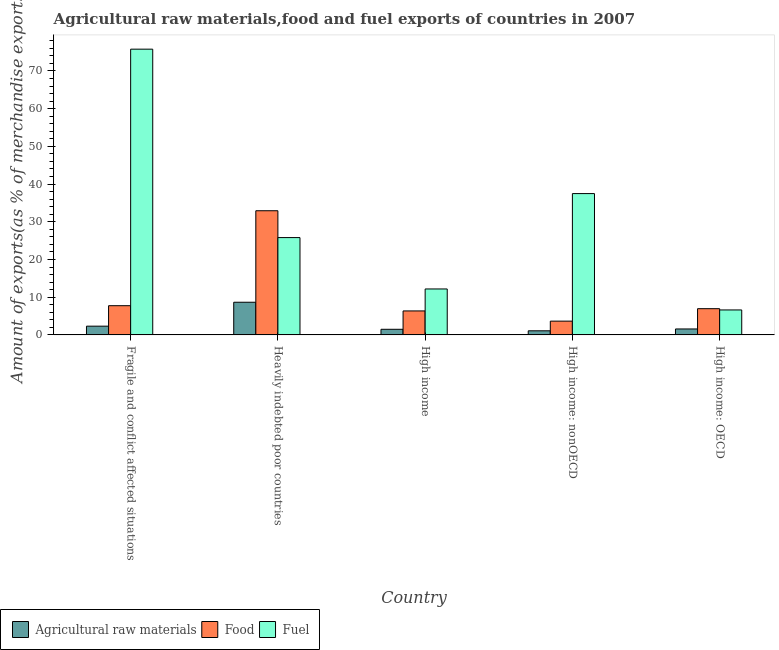How many different coloured bars are there?
Offer a terse response. 3. How many groups of bars are there?
Your answer should be very brief. 5. How many bars are there on the 4th tick from the right?
Make the answer very short. 3. What is the label of the 1st group of bars from the left?
Keep it short and to the point. Fragile and conflict affected situations. In how many cases, is the number of bars for a given country not equal to the number of legend labels?
Your answer should be very brief. 0. What is the percentage of food exports in High income: nonOECD?
Your response must be concise. 3.65. Across all countries, what is the maximum percentage of raw materials exports?
Offer a very short reply. 8.66. Across all countries, what is the minimum percentage of food exports?
Your answer should be very brief. 3.65. In which country was the percentage of raw materials exports maximum?
Keep it short and to the point. Heavily indebted poor countries. In which country was the percentage of raw materials exports minimum?
Provide a short and direct response. High income: nonOECD. What is the total percentage of fuel exports in the graph?
Offer a terse response. 157.86. What is the difference between the percentage of food exports in Heavily indebted poor countries and that in High income: OECD?
Your answer should be very brief. 25.97. What is the difference between the percentage of raw materials exports in High income: nonOECD and the percentage of fuel exports in Fragile and conflict affected situations?
Make the answer very short. -74.68. What is the average percentage of raw materials exports per country?
Your response must be concise. 3.03. What is the difference between the percentage of fuel exports and percentage of food exports in High income: OECD?
Your response must be concise. -0.33. In how many countries, is the percentage of food exports greater than 14 %?
Make the answer very short. 1. What is the ratio of the percentage of food exports in Fragile and conflict affected situations to that in High income?
Your answer should be compact. 1.22. Is the percentage of fuel exports in Fragile and conflict affected situations less than that in High income: OECD?
Offer a very short reply. No. Is the difference between the percentage of food exports in Heavily indebted poor countries and High income: nonOECD greater than the difference between the percentage of raw materials exports in Heavily indebted poor countries and High income: nonOECD?
Your answer should be compact. Yes. What is the difference between the highest and the second highest percentage of food exports?
Offer a very short reply. 25.18. What is the difference between the highest and the lowest percentage of fuel exports?
Make the answer very short. 69.15. In how many countries, is the percentage of food exports greater than the average percentage of food exports taken over all countries?
Your response must be concise. 1. Is the sum of the percentage of fuel exports in Fragile and conflict affected situations and Heavily indebted poor countries greater than the maximum percentage of food exports across all countries?
Your answer should be compact. Yes. What does the 3rd bar from the left in Heavily indebted poor countries represents?
Give a very brief answer. Fuel. What does the 1st bar from the right in High income: OECD represents?
Ensure brevity in your answer.  Fuel. Are all the bars in the graph horizontal?
Offer a very short reply. No. How many countries are there in the graph?
Offer a very short reply. 5. Does the graph contain any zero values?
Your answer should be compact. No. How many legend labels are there?
Give a very brief answer. 3. How are the legend labels stacked?
Ensure brevity in your answer.  Horizontal. What is the title of the graph?
Provide a short and direct response. Agricultural raw materials,food and fuel exports of countries in 2007. Does "Tertiary" appear as one of the legend labels in the graph?
Offer a terse response. No. What is the label or title of the Y-axis?
Keep it short and to the point. Amount of exports(as % of merchandise exports). What is the Amount of exports(as % of merchandise exports) in Agricultural raw materials in Fragile and conflict affected situations?
Make the answer very short. 2.32. What is the Amount of exports(as % of merchandise exports) in Food in Fragile and conflict affected situations?
Give a very brief answer. 7.75. What is the Amount of exports(as % of merchandise exports) in Fuel in Fragile and conflict affected situations?
Give a very brief answer. 75.77. What is the Amount of exports(as % of merchandise exports) in Agricultural raw materials in Heavily indebted poor countries?
Provide a succinct answer. 8.66. What is the Amount of exports(as % of merchandise exports) of Food in Heavily indebted poor countries?
Your response must be concise. 32.92. What is the Amount of exports(as % of merchandise exports) of Fuel in Heavily indebted poor countries?
Your response must be concise. 25.81. What is the Amount of exports(as % of merchandise exports) in Agricultural raw materials in High income?
Keep it short and to the point. 1.49. What is the Amount of exports(as % of merchandise exports) in Food in High income?
Provide a succinct answer. 6.36. What is the Amount of exports(as % of merchandise exports) in Fuel in High income?
Keep it short and to the point. 12.18. What is the Amount of exports(as % of merchandise exports) in Agricultural raw materials in High income: nonOECD?
Keep it short and to the point. 1.09. What is the Amount of exports(as % of merchandise exports) in Food in High income: nonOECD?
Your response must be concise. 3.65. What is the Amount of exports(as % of merchandise exports) of Fuel in High income: nonOECD?
Give a very brief answer. 37.48. What is the Amount of exports(as % of merchandise exports) in Agricultural raw materials in High income: OECD?
Ensure brevity in your answer.  1.58. What is the Amount of exports(as % of merchandise exports) of Food in High income: OECD?
Keep it short and to the point. 6.95. What is the Amount of exports(as % of merchandise exports) in Fuel in High income: OECD?
Offer a terse response. 6.62. Across all countries, what is the maximum Amount of exports(as % of merchandise exports) in Agricultural raw materials?
Keep it short and to the point. 8.66. Across all countries, what is the maximum Amount of exports(as % of merchandise exports) of Food?
Make the answer very short. 32.92. Across all countries, what is the maximum Amount of exports(as % of merchandise exports) of Fuel?
Keep it short and to the point. 75.77. Across all countries, what is the minimum Amount of exports(as % of merchandise exports) of Agricultural raw materials?
Keep it short and to the point. 1.09. Across all countries, what is the minimum Amount of exports(as % of merchandise exports) in Food?
Ensure brevity in your answer.  3.65. Across all countries, what is the minimum Amount of exports(as % of merchandise exports) of Fuel?
Give a very brief answer. 6.62. What is the total Amount of exports(as % of merchandise exports) in Agricultural raw materials in the graph?
Provide a succinct answer. 15.14. What is the total Amount of exports(as % of merchandise exports) in Food in the graph?
Offer a very short reply. 57.63. What is the total Amount of exports(as % of merchandise exports) of Fuel in the graph?
Offer a very short reply. 157.86. What is the difference between the Amount of exports(as % of merchandise exports) of Agricultural raw materials in Fragile and conflict affected situations and that in Heavily indebted poor countries?
Keep it short and to the point. -6.34. What is the difference between the Amount of exports(as % of merchandise exports) in Food in Fragile and conflict affected situations and that in Heavily indebted poor countries?
Give a very brief answer. -25.18. What is the difference between the Amount of exports(as % of merchandise exports) in Fuel in Fragile and conflict affected situations and that in Heavily indebted poor countries?
Ensure brevity in your answer.  49.96. What is the difference between the Amount of exports(as % of merchandise exports) in Agricultural raw materials in Fragile and conflict affected situations and that in High income?
Your answer should be compact. 0.83. What is the difference between the Amount of exports(as % of merchandise exports) of Food in Fragile and conflict affected situations and that in High income?
Your answer should be very brief. 1.39. What is the difference between the Amount of exports(as % of merchandise exports) in Fuel in Fragile and conflict affected situations and that in High income?
Provide a succinct answer. 63.59. What is the difference between the Amount of exports(as % of merchandise exports) of Agricultural raw materials in Fragile and conflict affected situations and that in High income: nonOECD?
Offer a terse response. 1.23. What is the difference between the Amount of exports(as % of merchandise exports) of Food in Fragile and conflict affected situations and that in High income: nonOECD?
Give a very brief answer. 4.09. What is the difference between the Amount of exports(as % of merchandise exports) in Fuel in Fragile and conflict affected situations and that in High income: nonOECD?
Your answer should be very brief. 38.29. What is the difference between the Amount of exports(as % of merchandise exports) of Agricultural raw materials in Fragile and conflict affected situations and that in High income: OECD?
Your response must be concise. 0.74. What is the difference between the Amount of exports(as % of merchandise exports) of Food in Fragile and conflict affected situations and that in High income: OECD?
Provide a succinct answer. 0.79. What is the difference between the Amount of exports(as % of merchandise exports) of Fuel in Fragile and conflict affected situations and that in High income: OECD?
Give a very brief answer. 69.15. What is the difference between the Amount of exports(as % of merchandise exports) in Agricultural raw materials in Heavily indebted poor countries and that in High income?
Keep it short and to the point. 7.17. What is the difference between the Amount of exports(as % of merchandise exports) in Food in Heavily indebted poor countries and that in High income?
Provide a short and direct response. 26.57. What is the difference between the Amount of exports(as % of merchandise exports) of Fuel in Heavily indebted poor countries and that in High income?
Your answer should be very brief. 13.62. What is the difference between the Amount of exports(as % of merchandise exports) in Agricultural raw materials in Heavily indebted poor countries and that in High income: nonOECD?
Your answer should be compact. 7.57. What is the difference between the Amount of exports(as % of merchandise exports) of Food in Heavily indebted poor countries and that in High income: nonOECD?
Ensure brevity in your answer.  29.27. What is the difference between the Amount of exports(as % of merchandise exports) of Fuel in Heavily indebted poor countries and that in High income: nonOECD?
Ensure brevity in your answer.  -11.67. What is the difference between the Amount of exports(as % of merchandise exports) of Agricultural raw materials in Heavily indebted poor countries and that in High income: OECD?
Offer a very short reply. 7.08. What is the difference between the Amount of exports(as % of merchandise exports) of Food in Heavily indebted poor countries and that in High income: OECD?
Your answer should be very brief. 25.97. What is the difference between the Amount of exports(as % of merchandise exports) in Fuel in Heavily indebted poor countries and that in High income: OECD?
Your answer should be compact. 19.18. What is the difference between the Amount of exports(as % of merchandise exports) in Agricultural raw materials in High income and that in High income: nonOECD?
Give a very brief answer. 0.4. What is the difference between the Amount of exports(as % of merchandise exports) in Food in High income and that in High income: nonOECD?
Keep it short and to the point. 2.71. What is the difference between the Amount of exports(as % of merchandise exports) in Fuel in High income and that in High income: nonOECD?
Ensure brevity in your answer.  -25.29. What is the difference between the Amount of exports(as % of merchandise exports) in Agricultural raw materials in High income and that in High income: OECD?
Offer a terse response. -0.09. What is the difference between the Amount of exports(as % of merchandise exports) of Food in High income and that in High income: OECD?
Your answer should be very brief. -0.6. What is the difference between the Amount of exports(as % of merchandise exports) in Fuel in High income and that in High income: OECD?
Provide a short and direct response. 5.56. What is the difference between the Amount of exports(as % of merchandise exports) in Agricultural raw materials in High income: nonOECD and that in High income: OECD?
Keep it short and to the point. -0.49. What is the difference between the Amount of exports(as % of merchandise exports) in Food in High income: nonOECD and that in High income: OECD?
Provide a succinct answer. -3.3. What is the difference between the Amount of exports(as % of merchandise exports) of Fuel in High income: nonOECD and that in High income: OECD?
Keep it short and to the point. 30.85. What is the difference between the Amount of exports(as % of merchandise exports) in Agricultural raw materials in Fragile and conflict affected situations and the Amount of exports(as % of merchandise exports) in Food in Heavily indebted poor countries?
Provide a succinct answer. -30.6. What is the difference between the Amount of exports(as % of merchandise exports) of Agricultural raw materials in Fragile and conflict affected situations and the Amount of exports(as % of merchandise exports) of Fuel in Heavily indebted poor countries?
Give a very brief answer. -23.48. What is the difference between the Amount of exports(as % of merchandise exports) of Food in Fragile and conflict affected situations and the Amount of exports(as % of merchandise exports) of Fuel in Heavily indebted poor countries?
Keep it short and to the point. -18.06. What is the difference between the Amount of exports(as % of merchandise exports) of Agricultural raw materials in Fragile and conflict affected situations and the Amount of exports(as % of merchandise exports) of Food in High income?
Keep it short and to the point. -4.04. What is the difference between the Amount of exports(as % of merchandise exports) of Agricultural raw materials in Fragile and conflict affected situations and the Amount of exports(as % of merchandise exports) of Fuel in High income?
Your answer should be compact. -9.86. What is the difference between the Amount of exports(as % of merchandise exports) in Food in Fragile and conflict affected situations and the Amount of exports(as % of merchandise exports) in Fuel in High income?
Make the answer very short. -4.44. What is the difference between the Amount of exports(as % of merchandise exports) in Agricultural raw materials in Fragile and conflict affected situations and the Amount of exports(as % of merchandise exports) in Food in High income: nonOECD?
Offer a terse response. -1.33. What is the difference between the Amount of exports(as % of merchandise exports) in Agricultural raw materials in Fragile and conflict affected situations and the Amount of exports(as % of merchandise exports) in Fuel in High income: nonOECD?
Ensure brevity in your answer.  -35.15. What is the difference between the Amount of exports(as % of merchandise exports) in Food in Fragile and conflict affected situations and the Amount of exports(as % of merchandise exports) in Fuel in High income: nonOECD?
Your answer should be very brief. -29.73. What is the difference between the Amount of exports(as % of merchandise exports) in Agricultural raw materials in Fragile and conflict affected situations and the Amount of exports(as % of merchandise exports) in Food in High income: OECD?
Keep it short and to the point. -4.63. What is the difference between the Amount of exports(as % of merchandise exports) of Agricultural raw materials in Fragile and conflict affected situations and the Amount of exports(as % of merchandise exports) of Fuel in High income: OECD?
Ensure brevity in your answer.  -4.3. What is the difference between the Amount of exports(as % of merchandise exports) in Food in Fragile and conflict affected situations and the Amount of exports(as % of merchandise exports) in Fuel in High income: OECD?
Provide a short and direct response. 1.12. What is the difference between the Amount of exports(as % of merchandise exports) in Agricultural raw materials in Heavily indebted poor countries and the Amount of exports(as % of merchandise exports) in Food in High income?
Offer a terse response. 2.3. What is the difference between the Amount of exports(as % of merchandise exports) of Agricultural raw materials in Heavily indebted poor countries and the Amount of exports(as % of merchandise exports) of Fuel in High income?
Offer a very short reply. -3.52. What is the difference between the Amount of exports(as % of merchandise exports) in Food in Heavily indebted poor countries and the Amount of exports(as % of merchandise exports) in Fuel in High income?
Give a very brief answer. 20.74. What is the difference between the Amount of exports(as % of merchandise exports) of Agricultural raw materials in Heavily indebted poor countries and the Amount of exports(as % of merchandise exports) of Food in High income: nonOECD?
Offer a terse response. 5.01. What is the difference between the Amount of exports(as % of merchandise exports) of Agricultural raw materials in Heavily indebted poor countries and the Amount of exports(as % of merchandise exports) of Fuel in High income: nonOECD?
Your answer should be very brief. -28.81. What is the difference between the Amount of exports(as % of merchandise exports) in Food in Heavily indebted poor countries and the Amount of exports(as % of merchandise exports) in Fuel in High income: nonOECD?
Your answer should be very brief. -4.55. What is the difference between the Amount of exports(as % of merchandise exports) in Agricultural raw materials in Heavily indebted poor countries and the Amount of exports(as % of merchandise exports) in Food in High income: OECD?
Offer a very short reply. 1.71. What is the difference between the Amount of exports(as % of merchandise exports) in Agricultural raw materials in Heavily indebted poor countries and the Amount of exports(as % of merchandise exports) in Fuel in High income: OECD?
Offer a terse response. 2.04. What is the difference between the Amount of exports(as % of merchandise exports) in Food in Heavily indebted poor countries and the Amount of exports(as % of merchandise exports) in Fuel in High income: OECD?
Provide a short and direct response. 26.3. What is the difference between the Amount of exports(as % of merchandise exports) in Agricultural raw materials in High income and the Amount of exports(as % of merchandise exports) in Food in High income: nonOECD?
Your response must be concise. -2.16. What is the difference between the Amount of exports(as % of merchandise exports) in Agricultural raw materials in High income and the Amount of exports(as % of merchandise exports) in Fuel in High income: nonOECD?
Offer a terse response. -35.98. What is the difference between the Amount of exports(as % of merchandise exports) of Food in High income and the Amount of exports(as % of merchandise exports) of Fuel in High income: nonOECD?
Ensure brevity in your answer.  -31.12. What is the difference between the Amount of exports(as % of merchandise exports) in Agricultural raw materials in High income and the Amount of exports(as % of merchandise exports) in Food in High income: OECD?
Offer a very short reply. -5.46. What is the difference between the Amount of exports(as % of merchandise exports) of Agricultural raw materials in High income and the Amount of exports(as % of merchandise exports) of Fuel in High income: OECD?
Offer a terse response. -5.13. What is the difference between the Amount of exports(as % of merchandise exports) of Food in High income and the Amount of exports(as % of merchandise exports) of Fuel in High income: OECD?
Provide a short and direct response. -0.26. What is the difference between the Amount of exports(as % of merchandise exports) in Agricultural raw materials in High income: nonOECD and the Amount of exports(as % of merchandise exports) in Food in High income: OECD?
Provide a succinct answer. -5.87. What is the difference between the Amount of exports(as % of merchandise exports) of Agricultural raw materials in High income: nonOECD and the Amount of exports(as % of merchandise exports) of Fuel in High income: OECD?
Provide a short and direct response. -5.53. What is the difference between the Amount of exports(as % of merchandise exports) of Food in High income: nonOECD and the Amount of exports(as % of merchandise exports) of Fuel in High income: OECD?
Provide a short and direct response. -2.97. What is the average Amount of exports(as % of merchandise exports) of Agricultural raw materials per country?
Provide a succinct answer. 3.03. What is the average Amount of exports(as % of merchandise exports) in Food per country?
Your response must be concise. 11.53. What is the average Amount of exports(as % of merchandise exports) in Fuel per country?
Give a very brief answer. 31.57. What is the difference between the Amount of exports(as % of merchandise exports) in Agricultural raw materials and Amount of exports(as % of merchandise exports) in Food in Fragile and conflict affected situations?
Your response must be concise. -5.42. What is the difference between the Amount of exports(as % of merchandise exports) in Agricultural raw materials and Amount of exports(as % of merchandise exports) in Fuel in Fragile and conflict affected situations?
Make the answer very short. -73.45. What is the difference between the Amount of exports(as % of merchandise exports) in Food and Amount of exports(as % of merchandise exports) in Fuel in Fragile and conflict affected situations?
Give a very brief answer. -68.02. What is the difference between the Amount of exports(as % of merchandise exports) of Agricultural raw materials and Amount of exports(as % of merchandise exports) of Food in Heavily indebted poor countries?
Make the answer very short. -24.26. What is the difference between the Amount of exports(as % of merchandise exports) in Agricultural raw materials and Amount of exports(as % of merchandise exports) in Fuel in Heavily indebted poor countries?
Ensure brevity in your answer.  -17.14. What is the difference between the Amount of exports(as % of merchandise exports) in Food and Amount of exports(as % of merchandise exports) in Fuel in Heavily indebted poor countries?
Keep it short and to the point. 7.12. What is the difference between the Amount of exports(as % of merchandise exports) in Agricultural raw materials and Amount of exports(as % of merchandise exports) in Food in High income?
Make the answer very short. -4.87. What is the difference between the Amount of exports(as % of merchandise exports) in Agricultural raw materials and Amount of exports(as % of merchandise exports) in Fuel in High income?
Make the answer very short. -10.69. What is the difference between the Amount of exports(as % of merchandise exports) in Food and Amount of exports(as % of merchandise exports) in Fuel in High income?
Keep it short and to the point. -5.83. What is the difference between the Amount of exports(as % of merchandise exports) in Agricultural raw materials and Amount of exports(as % of merchandise exports) in Food in High income: nonOECD?
Your response must be concise. -2.56. What is the difference between the Amount of exports(as % of merchandise exports) in Agricultural raw materials and Amount of exports(as % of merchandise exports) in Fuel in High income: nonOECD?
Offer a very short reply. -36.39. What is the difference between the Amount of exports(as % of merchandise exports) in Food and Amount of exports(as % of merchandise exports) in Fuel in High income: nonOECD?
Your answer should be very brief. -33.82. What is the difference between the Amount of exports(as % of merchandise exports) of Agricultural raw materials and Amount of exports(as % of merchandise exports) of Food in High income: OECD?
Make the answer very short. -5.38. What is the difference between the Amount of exports(as % of merchandise exports) in Agricultural raw materials and Amount of exports(as % of merchandise exports) in Fuel in High income: OECD?
Provide a succinct answer. -5.04. What is the difference between the Amount of exports(as % of merchandise exports) in Food and Amount of exports(as % of merchandise exports) in Fuel in High income: OECD?
Your response must be concise. 0.33. What is the ratio of the Amount of exports(as % of merchandise exports) of Agricultural raw materials in Fragile and conflict affected situations to that in Heavily indebted poor countries?
Give a very brief answer. 0.27. What is the ratio of the Amount of exports(as % of merchandise exports) in Food in Fragile and conflict affected situations to that in Heavily indebted poor countries?
Ensure brevity in your answer.  0.24. What is the ratio of the Amount of exports(as % of merchandise exports) in Fuel in Fragile and conflict affected situations to that in Heavily indebted poor countries?
Provide a succinct answer. 2.94. What is the ratio of the Amount of exports(as % of merchandise exports) of Agricultural raw materials in Fragile and conflict affected situations to that in High income?
Keep it short and to the point. 1.56. What is the ratio of the Amount of exports(as % of merchandise exports) in Food in Fragile and conflict affected situations to that in High income?
Ensure brevity in your answer.  1.22. What is the ratio of the Amount of exports(as % of merchandise exports) of Fuel in Fragile and conflict affected situations to that in High income?
Give a very brief answer. 6.22. What is the ratio of the Amount of exports(as % of merchandise exports) of Agricultural raw materials in Fragile and conflict affected situations to that in High income: nonOECD?
Provide a succinct answer. 2.13. What is the ratio of the Amount of exports(as % of merchandise exports) of Food in Fragile and conflict affected situations to that in High income: nonOECD?
Your answer should be compact. 2.12. What is the ratio of the Amount of exports(as % of merchandise exports) of Fuel in Fragile and conflict affected situations to that in High income: nonOECD?
Provide a succinct answer. 2.02. What is the ratio of the Amount of exports(as % of merchandise exports) of Agricultural raw materials in Fragile and conflict affected situations to that in High income: OECD?
Make the answer very short. 1.47. What is the ratio of the Amount of exports(as % of merchandise exports) in Food in Fragile and conflict affected situations to that in High income: OECD?
Your answer should be compact. 1.11. What is the ratio of the Amount of exports(as % of merchandise exports) of Fuel in Fragile and conflict affected situations to that in High income: OECD?
Offer a very short reply. 11.44. What is the ratio of the Amount of exports(as % of merchandise exports) of Agricultural raw materials in Heavily indebted poor countries to that in High income?
Your response must be concise. 5.81. What is the ratio of the Amount of exports(as % of merchandise exports) of Food in Heavily indebted poor countries to that in High income?
Offer a terse response. 5.18. What is the ratio of the Amount of exports(as % of merchandise exports) of Fuel in Heavily indebted poor countries to that in High income?
Give a very brief answer. 2.12. What is the ratio of the Amount of exports(as % of merchandise exports) in Agricultural raw materials in Heavily indebted poor countries to that in High income: nonOECD?
Ensure brevity in your answer.  7.95. What is the ratio of the Amount of exports(as % of merchandise exports) of Food in Heavily indebted poor countries to that in High income: nonOECD?
Offer a terse response. 9.02. What is the ratio of the Amount of exports(as % of merchandise exports) in Fuel in Heavily indebted poor countries to that in High income: nonOECD?
Provide a succinct answer. 0.69. What is the ratio of the Amount of exports(as % of merchandise exports) of Agricultural raw materials in Heavily indebted poor countries to that in High income: OECD?
Keep it short and to the point. 5.49. What is the ratio of the Amount of exports(as % of merchandise exports) in Food in Heavily indebted poor countries to that in High income: OECD?
Your answer should be compact. 4.73. What is the ratio of the Amount of exports(as % of merchandise exports) in Fuel in Heavily indebted poor countries to that in High income: OECD?
Offer a very short reply. 3.9. What is the ratio of the Amount of exports(as % of merchandise exports) in Agricultural raw materials in High income to that in High income: nonOECD?
Offer a terse response. 1.37. What is the ratio of the Amount of exports(as % of merchandise exports) of Food in High income to that in High income: nonOECD?
Keep it short and to the point. 1.74. What is the ratio of the Amount of exports(as % of merchandise exports) of Fuel in High income to that in High income: nonOECD?
Give a very brief answer. 0.33. What is the ratio of the Amount of exports(as % of merchandise exports) of Agricultural raw materials in High income to that in High income: OECD?
Offer a terse response. 0.94. What is the ratio of the Amount of exports(as % of merchandise exports) in Food in High income to that in High income: OECD?
Offer a terse response. 0.91. What is the ratio of the Amount of exports(as % of merchandise exports) in Fuel in High income to that in High income: OECD?
Ensure brevity in your answer.  1.84. What is the ratio of the Amount of exports(as % of merchandise exports) in Agricultural raw materials in High income: nonOECD to that in High income: OECD?
Give a very brief answer. 0.69. What is the ratio of the Amount of exports(as % of merchandise exports) in Food in High income: nonOECD to that in High income: OECD?
Provide a succinct answer. 0.53. What is the ratio of the Amount of exports(as % of merchandise exports) in Fuel in High income: nonOECD to that in High income: OECD?
Provide a succinct answer. 5.66. What is the difference between the highest and the second highest Amount of exports(as % of merchandise exports) of Agricultural raw materials?
Keep it short and to the point. 6.34. What is the difference between the highest and the second highest Amount of exports(as % of merchandise exports) of Food?
Provide a succinct answer. 25.18. What is the difference between the highest and the second highest Amount of exports(as % of merchandise exports) in Fuel?
Keep it short and to the point. 38.29. What is the difference between the highest and the lowest Amount of exports(as % of merchandise exports) in Agricultural raw materials?
Your answer should be compact. 7.57. What is the difference between the highest and the lowest Amount of exports(as % of merchandise exports) of Food?
Provide a succinct answer. 29.27. What is the difference between the highest and the lowest Amount of exports(as % of merchandise exports) of Fuel?
Ensure brevity in your answer.  69.15. 